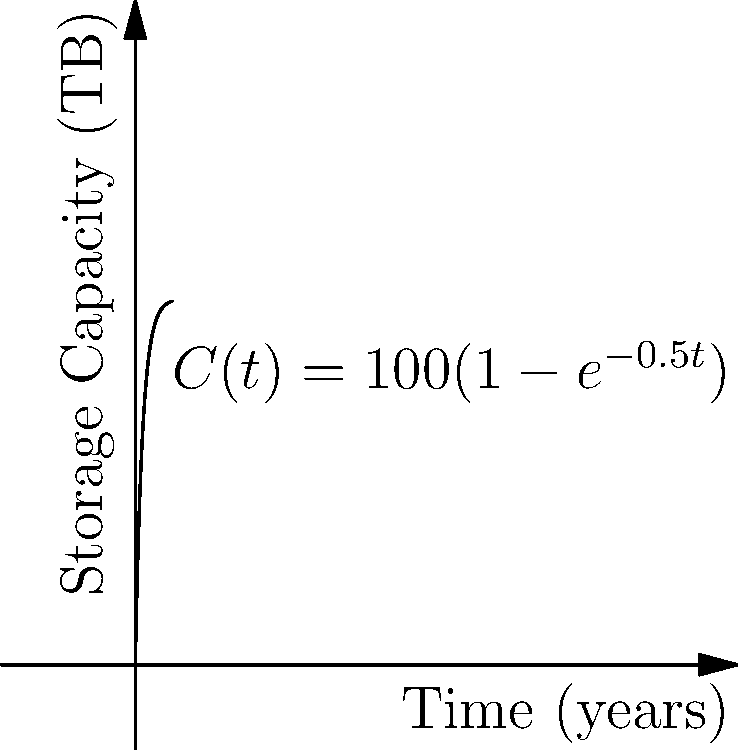The graph shows the growth of data storage capacity $C(t)$ in terabytes (TB) over time $t$ in years for a new technology you're introducing to the tribe. The function is given by $C(t) = 100(1-e^{-0.5t})$. At what rate (in TB/year) is the storage capacity increasing after 2 years? To find the rate of change of storage capacity after 2 years, we need to calculate the derivative of $C(t)$ and evaluate it at $t=2$:

1) First, let's find $C'(t)$:
   $C'(t) = 100 \cdot \frac{d}{dt}(1-e^{-0.5t})$
   $C'(t) = 100 \cdot (0.5e^{-0.5t})$
   $C'(t) = 50e^{-0.5t}$

2) Now, we evaluate $C'(2)$:
   $C'(2) = 50e^{-0.5(2)}$
   $C'(2) = 50e^{-1}$

3) Calculate the value:
   $C'(2) = 50 \cdot \frac{1}{e} \approx 18.39$ TB/year

Therefore, after 2 years, the storage capacity is increasing at a rate of approximately 18.39 TB per year.
Answer: 18.39 TB/year 